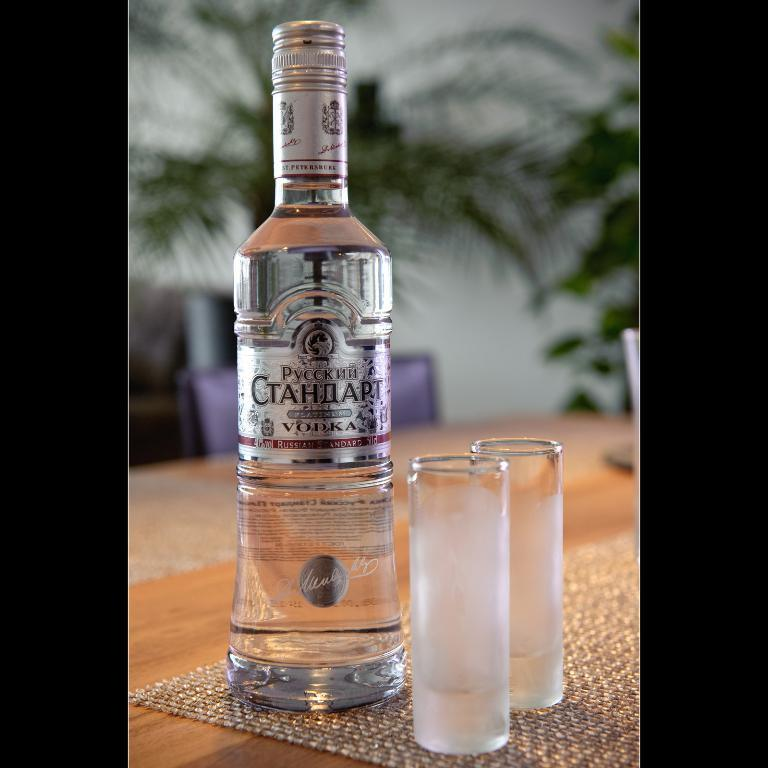<image>
Offer a succinct explanation of the picture presented. Bottle of vodka next to two shot glasses. 